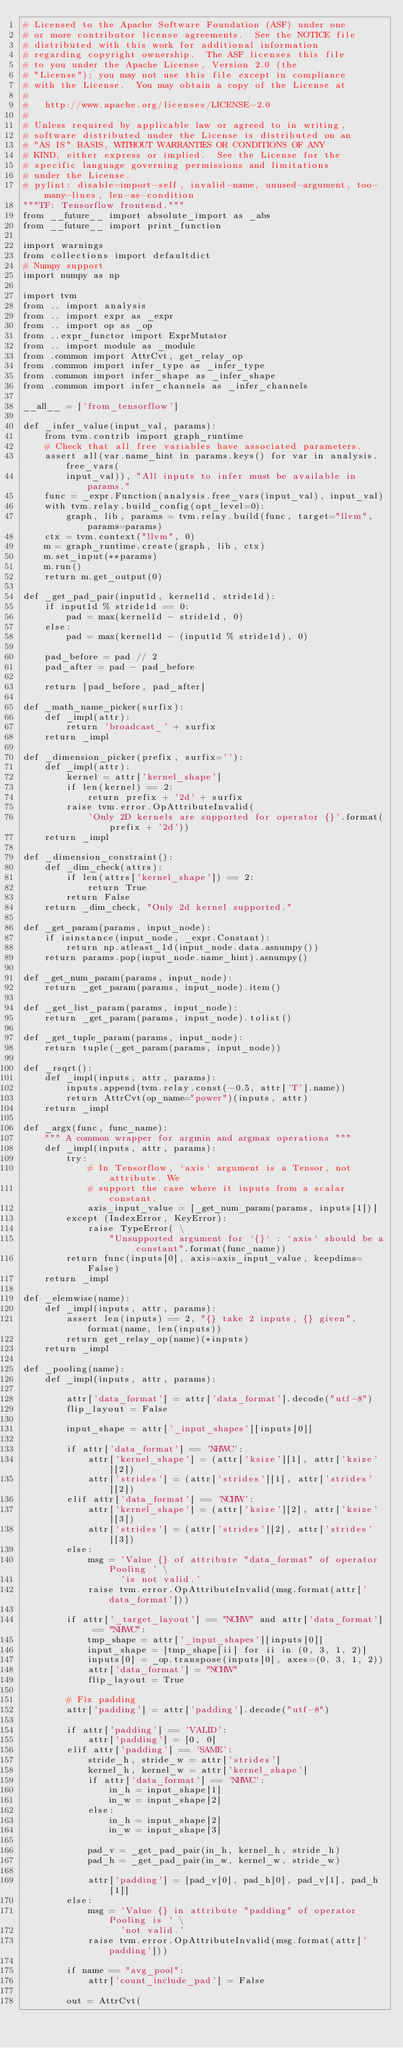<code> <loc_0><loc_0><loc_500><loc_500><_Python_># Licensed to the Apache Software Foundation (ASF) under one
# or more contributor license agreements.  See the NOTICE file
# distributed with this work for additional information
# regarding copyright ownership.  The ASF licenses this file
# to you under the Apache License, Version 2.0 (the
# "License"); you may not use this file except in compliance
# with the License.  You may obtain a copy of the License at
#
#   http://www.apache.org/licenses/LICENSE-2.0
#
# Unless required by applicable law or agreed to in writing,
# software distributed under the License is distributed on an
# "AS IS" BASIS, WITHOUT WARRANTIES OR CONDITIONS OF ANY
# KIND, either express or implied.  See the License for the
# specific language governing permissions and limitations
# under the License.
# pylint: disable=import-self, invalid-name, unused-argument, too-many-lines, len-as-condition
"""TF: Tensorflow frontend."""
from __future__ import absolute_import as _abs
from __future__ import print_function

import warnings
from collections import defaultdict
# Numpy support
import numpy as np

import tvm
from .. import analysis
from .. import expr as _expr
from .. import op as _op
from ..expr_functor import ExprMutator
from .. import module as _module
from .common import AttrCvt, get_relay_op
from .common import infer_type as _infer_type
from .common import infer_shape as _infer_shape
from .common import infer_channels as _infer_channels

__all__ = ['from_tensorflow']

def _infer_value(input_val, params):
    from tvm.contrib import graph_runtime
    # Check that all free variables have associated parameters.
    assert all(var.name_hint in params.keys() for var in analysis.free_vars(
        input_val)), "All inputs to infer must be available in params."
    func = _expr.Function(analysis.free_vars(input_val), input_val)
    with tvm.relay.build_config(opt_level=0):
        graph, lib, params = tvm.relay.build(func, target="llvm", params=params)
    ctx = tvm.context("llvm", 0)
    m = graph_runtime.create(graph, lib, ctx)
    m.set_input(**params)
    m.run()
    return m.get_output(0)

def _get_pad_pair(input1d, kernel1d, stride1d):
    if input1d % stride1d == 0:
        pad = max(kernel1d - stride1d, 0)
    else:
        pad = max(kernel1d - (input1d % stride1d), 0)

    pad_before = pad // 2
    pad_after = pad - pad_before

    return [pad_before, pad_after]

def _math_name_picker(surfix):
    def _impl(attr):
        return 'broadcast_' + surfix
    return _impl

def _dimension_picker(prefix, surfix=''):
    def _impl(attr):
        kernel = attr['kernel_shape']
        if len(kernel) == 2:
            return prefix + '2d' + surfix
        raise tvm.error.OpAttributeInvalid(
            'Only 2D kernels are supported for operator {}'.format(prefix + '2d'))
    return _impl

def _dimension_constraint():
    def _dim_check(attrs):
        if len(attrs['kernel_shape']) == 2:
            return True
        return False
    return _dim_check, "Only 2d kernel supported."

def _get_param(params, input_node):
    if isinstance(input_node, _expr.Constant):
        return np.atleast_1d(input_node.data.asnumpy())
    return params.pop(input_node.name_hint).asnumpy()

def _get_num_param(params, input_node):
    return _get_param(params, input_node).item()

def _get_list_param(params, input_node):
    return _get_param(params, input_node).tolist()

def _get_tuple_param(params, input_node):
    return tuple(_get_param(params, input_node))

def _rsqrt():
    def _impl(inputs, attr, params):
        inputs.append(tvm.relay.const(-0.5, attr['T'].name))
        return AttrCvt(op_name="power")(inputs, attr)
    return _impl

def _argx(func, func_name):
    """ A common wrapper for argmin and argmax operations """
    def _impl(inputs, attr, params):
        try:
            # In Tensorflow, `axis` argument is a Tensor, not attribute. We
            # support the case where it inputs from a scalar constant.
            axis_input_value = [_get_num_param(params, inputs[1])]
        except (IndexError, KeyError):
            raise TypeError( \
                "Unsupported argument for `{}` : `axis` should be a constant".format(func_name))
        return func(inputs[0], axis=axis_input_value, keepdims=False)
    return _impl

def _elemwise(name):
    def _impl(inputs, attr, params):
        assert len(inputs) == 2, "{} take 2 inputs, {} given".format(name, len(inputs))
        return get_relay_op(name)(*inputs)
    return _impl

def _pooling(name):
    def _impl(inputs, attr, params):

        attr['data_format'] = attr['data_format'].decode("utf-8")
        flip_layout = False

        input_shape = attr['_input_shapes'][inputs[0]]

        if attr['data_format'] == 'NHWC':
            attr['kernel_shape'] = (attr['ksize'][1], attr['ksize'][2])
            attr['strides'] = (attr['strides'][1], attr['strides'][2])
        elif attr['data_format'] == 'NCHW':
            attr['kernel_shape'] = (attr['ksize'][2], attr['ksize'][3])
            attr['strides'] = (attr['strides'][2], attr['strides'][3])
        else:
            msg = 'Value {} of attribute "data_format" of operator Pooling ' \
                  'is not valid.'
            raise tvm.error.OpAttributeInvalid(msg.format(attr['data_format']))

        if attr['_target_layout'] == "NCHW" and attr['data_format'] == "NHWC":
            tmp_shape = attr['_input_shapes'][inputs[0]]
            input_shape = [tmp_shape[ii] for ii in (0, 3, 1, 2)]
            inputs[0] = _op.transpose(inputs[0], axes=(0, 3, 1, 2))
            attr['data_format'] = "NCHW"
            flip_layout = True

        # Fix padding
        attr['padding'] = attr['padding'].decode("utf-8")

        if attr['padding'] == 'VALID':
            attr['padding'] = [0, 0]
        elif attr['padding'] == 'SAME':
            stride_h, stride_w = attr['strides']
            kernel_h, kernel_w = attr['kernel_shape']
            if attr['data_format'] == 'NHWC':
                in_h = input_shape[1]
                in_w = input_shape[2]
            else:
                in_h = input_shape[2]
                in_w = input_shape[3]

            pad_v = _get_pad_pair(in_h, kernel_h, stride_h)
            pad_h = _get_pad_pair(in_w, kernel_w, stride_w)

            attr['padding'] = [pad_v[0], pad_h[0], pad_v[1], pad_h[1]]
        else:
            msg = 'Value {} in attribute "padding" of operator Pooling is ' \
                  'not valid.'
            raise tvm.error.OpAttributeInvalid(msg.format(attr['padding']))

        if name == "avg_pool":
            attr['count_include_pad'] = False

        out = AttrCvt(</code> 